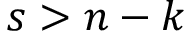<formula> <loc_0><loc_0><loc_500><loc_500>s > n - k</formula> 